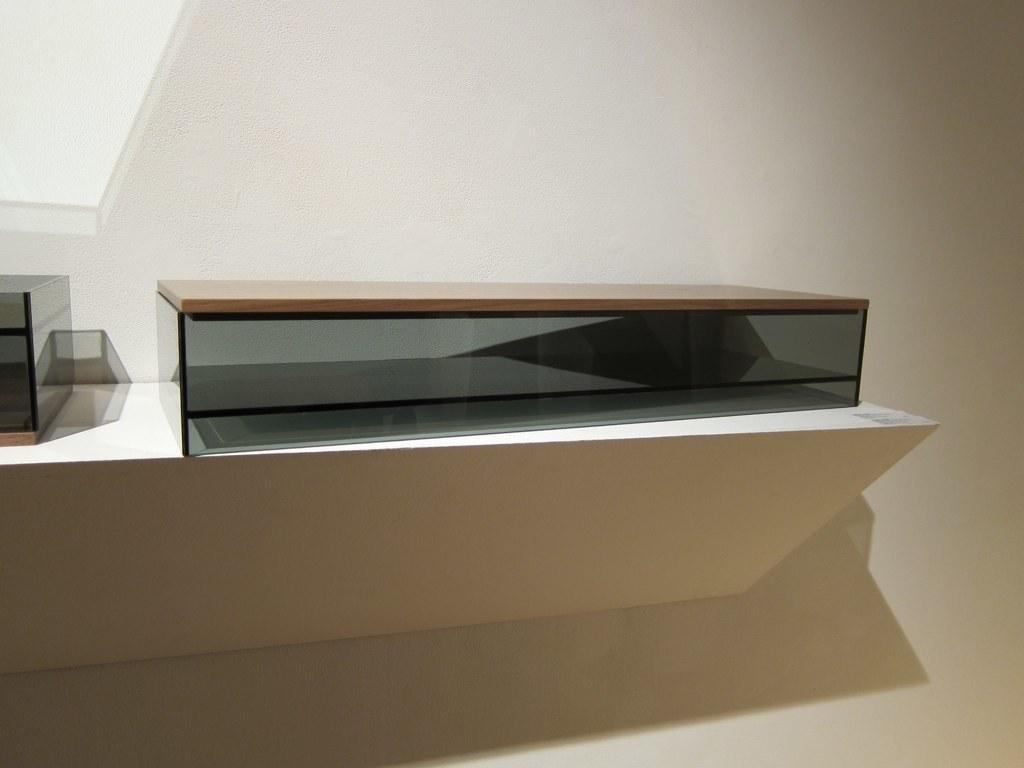Describe this image in one or two sentences. In the center of the picture we can see a desk and a glass object. In this picture we can see white wall. 